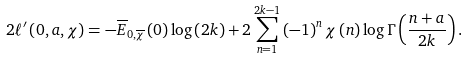<formula> <loc_0><loc_0><loc_500><loc_500>2 \ell ^ { \prime } \left ( 0 , a , \chi \right ) = - \overline { E } _ { 0 , \overline { \chi } } \left ( 0 \right ) \log \left ( 2 k \right ) + 2 \sum _ { n = 1 } ^ { 2 k - 1 } \left ( - 1 \right ) ^ { n } \chi \left ( n \right ) \log \Gamma \left ( \frac { n + a } { 2 k } \right ) .</formula> 